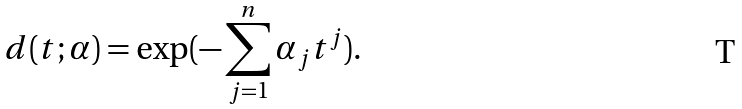<formula> <loc_0><loc_0><loc_500><loc_500>d ( t ; \alpha ) = \exp ( - \sum _ { j = 1 } ^ { n } \alpha _ { j } t ^ { j } ) .</formula> 